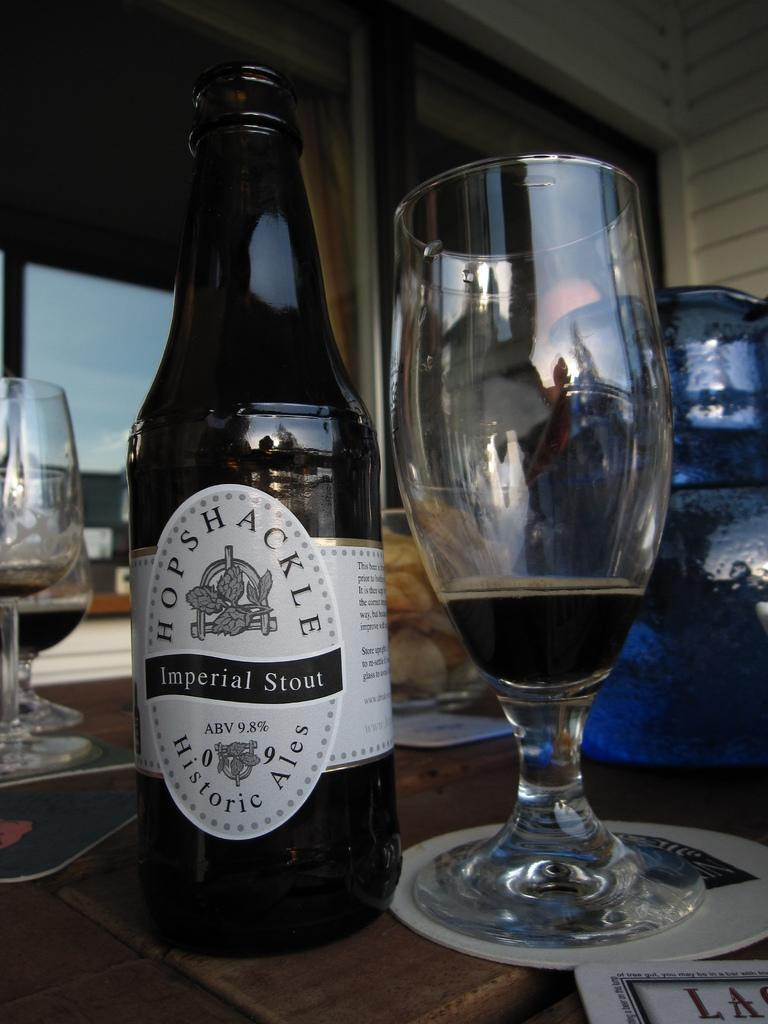What is present in the image that can hold a liquid? There is a bottle and a glass in the image that can hold a liquid. Where is the glass located in relation to the other objects in the image? The glass is in the center of the image. Are there any other glasses visible in the image? Yes, there are other glasses on the left side of the image. What type of protest is taking place in the image? There is no protest present in the image; it only features a bottle and glasses. Can you describe the wall surrounding the glasses in the image? There is no wall surrounding the glasses in the image. 